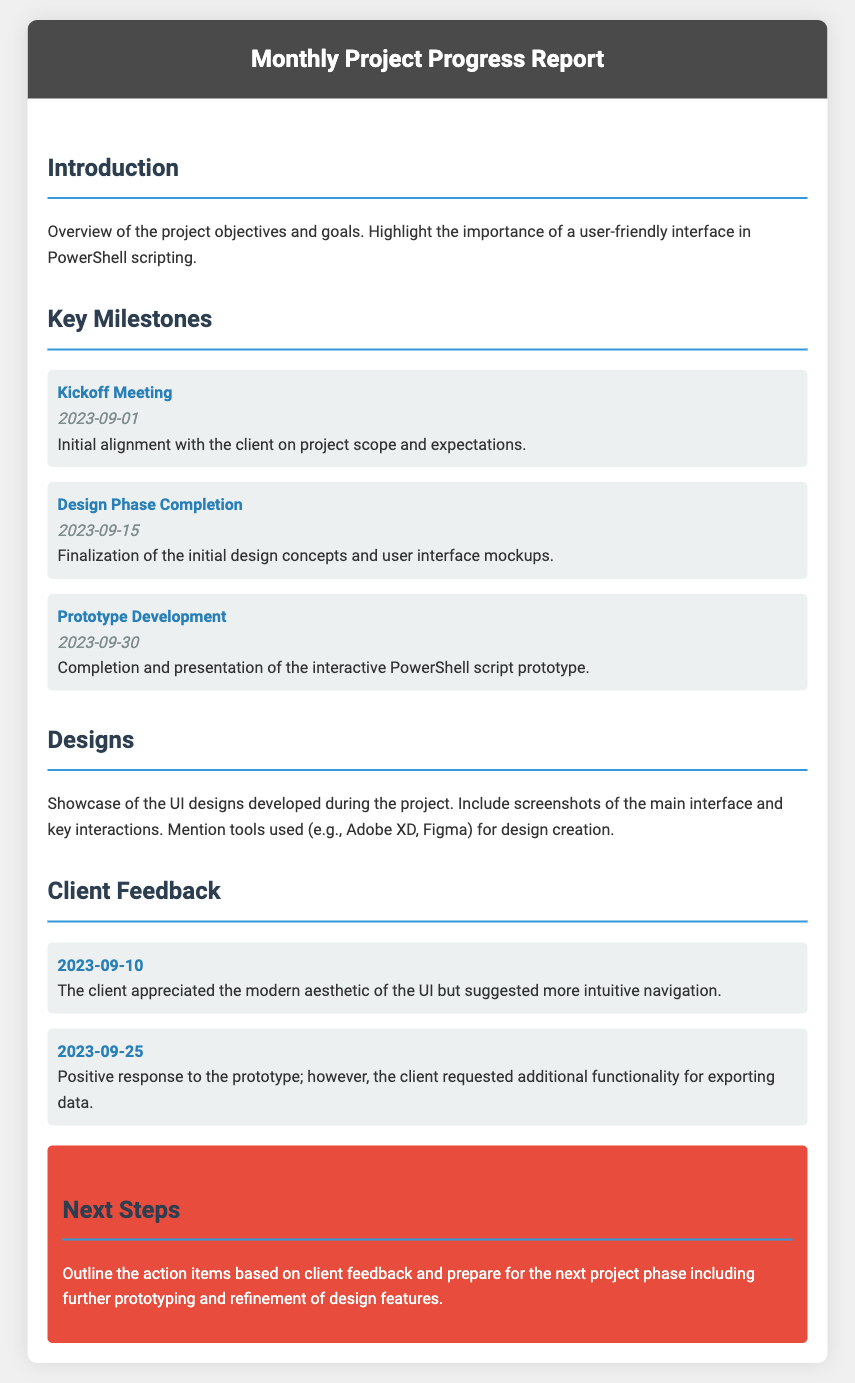what is the date of the kickoff meeting? The kickoff meeting is listed as occurring on September 1, 2023.
Answer: September 1, 2023 what milestone was completed on September 15, 2023? The milestone completed on this date is the Design Phase Completion.
Answer: Design Phase Completion how many pieces of client feedback were mentioned? There are two pieces of client feedback included in the document.
Answer: Two which design tool was mentioned for creating designs? The design tools mentioned include Adobe XD and Figma.
Answer: Adobe XD, Figma what was the client's feedback on the prototype? The client gave a positive response but requested additional functionality for exporting data.
Answer: Requested additional functionality for exporting data what is the main focus of the introduction section? The introduction emphasizes the importance of a user-friendly interface in PowerShell scripting.
Answer: User-friendly interface in PowerShell scripting when was the prototype development completed? The document states that the prototype development was completed on September 30, 2023.
Answer: September 30, 2023 what action items are outlined in the next steps section? The next steps outline action items based on client feedback and prepare for the next project phase.
Answer: Action items based on client feedback 